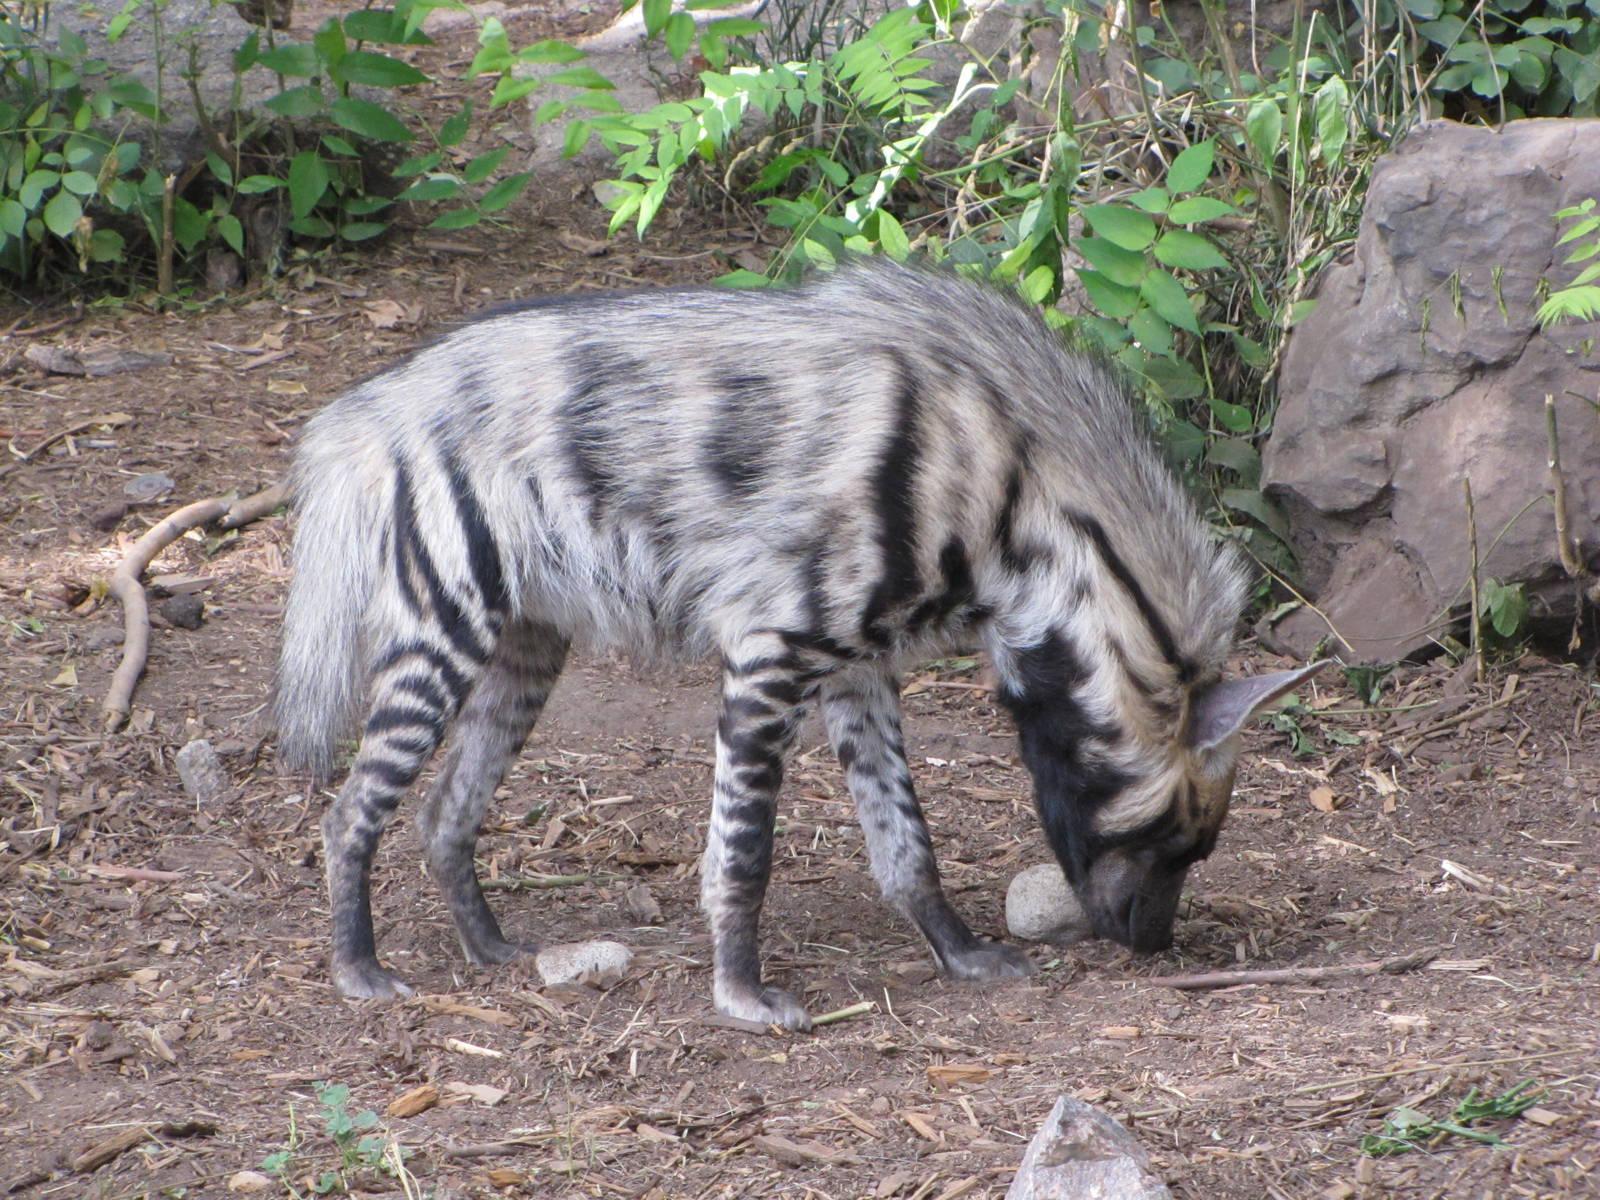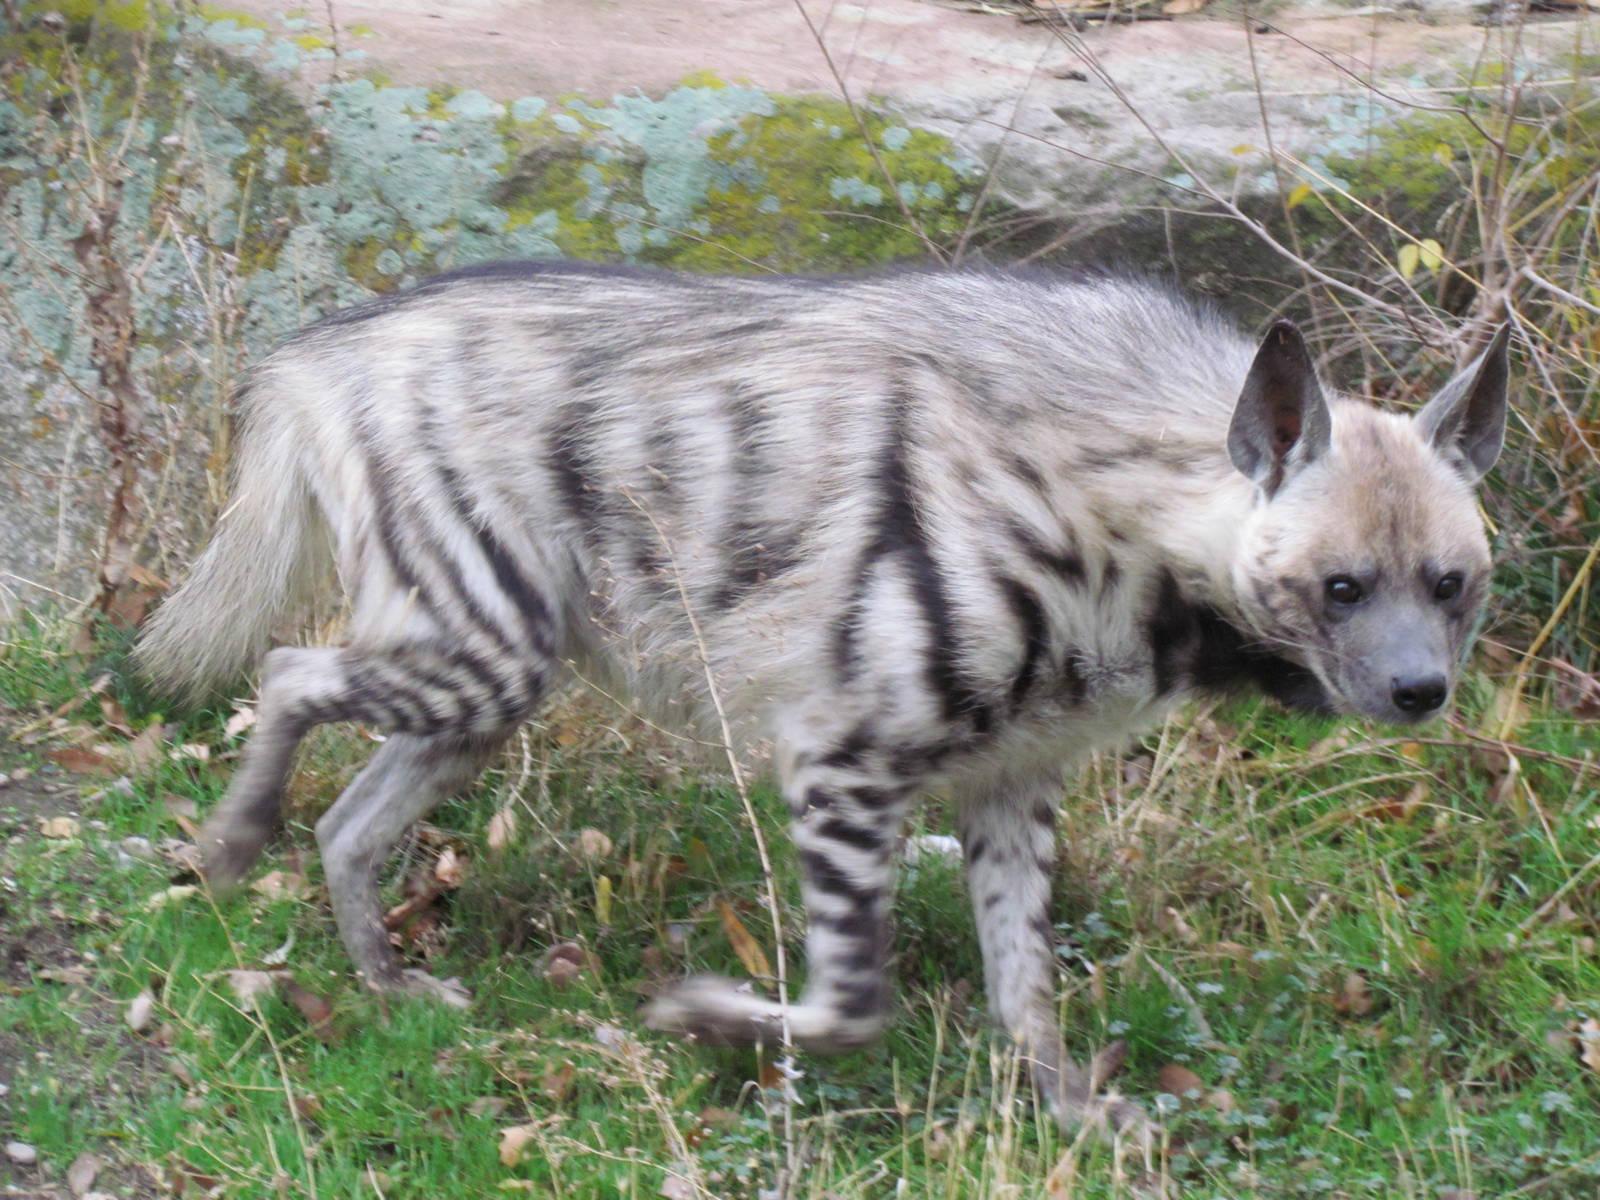The first image is the image on the left, the second image is the image on the right. Examine the images to the left and right. Is the description "There are two animals in the image on the left." accurate? Answer yes or no. No. The first image is the image on the left, the second image is the image on the right. For the images displayed, is the sentence "There is only one hyena in the left-hand image." factually correct? Answer yes or no. Yes. 